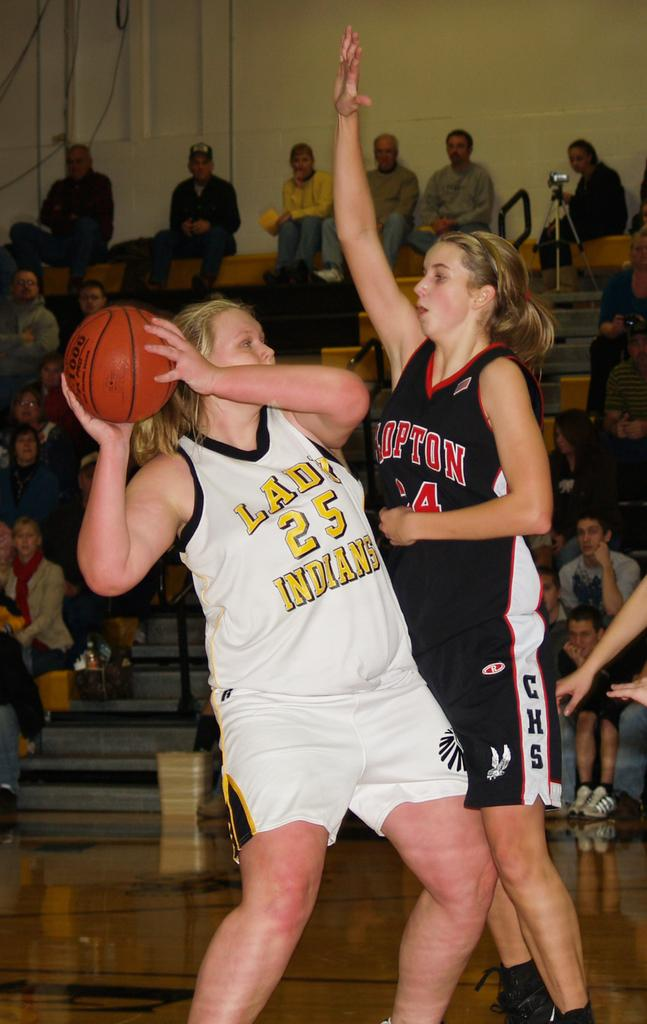<image>
Provide a brief description of the given image. the player has the number 25 on their jersey 